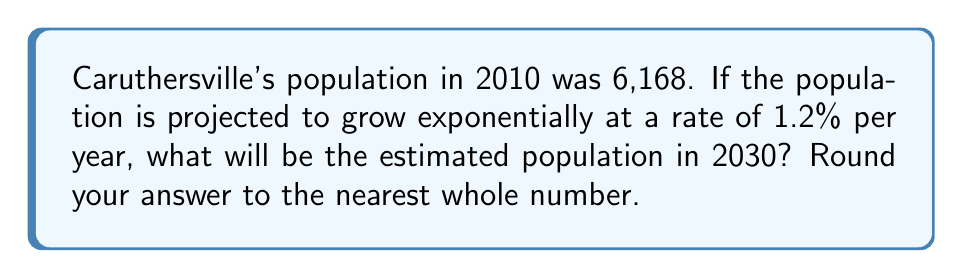Solve this math problem. Let's approach this step-by-step using the exponential growth formula:

1) The exponential growth formula is:
   $$A = P(1 + r)^t$$
   where:
   $A$ = final amount
   $P$ = initial amount
   $r$ = growth rate (as a decimal)
   $t$ = time period

2) We know:
   $P = 6,168$ (initial population in 2010)
   $r = 0.012$ (1.2% written as a decimal)
   $t = 20$ (number of years from 2010 to 2030)

3) Let's plug these values into our formula:
   $$A = 6,168(1 + 0.012)^{20}$$

4) Simplify inside the parentheses:
   $$A = 6,168(1.012)^{20}$$

5) Use a calculator to evaluate $(1.012)^{20}$:
   $$A = 6,168 \times 1.2682$$

6) Multiply:
   $$A = 7,822.3376$$

7) Rounding to the nearest whole number:
   $$A \approx 7,822$$

Therefore, the estimated population of Caruthersville in 2030 will be approximately 7,822 people.
Answer: 7,822 